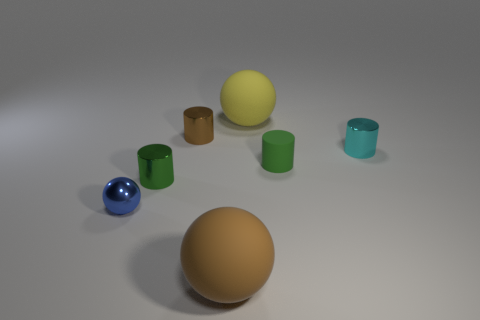What number of rubber things are big brown spheres or big yellow balls?
Ensure brevity in your answer.  2. There is a thing that is the same color as the matte cylinder; what is it made of?
Provide a short and direct response. Metal. Do the blue shiny sphere and the brown matte object have the same size?
Your answer should be very brief. No. How many things are either small spheres or matte balls that are in front of the small ball?
Offer a very short reply. 2. What material is the blue sphere that is the same size as the brown cylinder?
Your response must be concise. Metal. What is the cylinder that is behind the small rubber cylinder and on the right side of the yellow object made of?
Make the answer very short. Metal. Are there any cylinders that are behind the large yellow matte thing right of the tiny blue object?
Provide a short and direct response. No. What size is the object that is both right of the brown rubber thing and behind the cyan thing?
Ensure brevity in your answer.  Large. What number of purple things are either small cubes or small matte cylinders?
Offer a terse response. 0. What is the shape of the cyan metal object that is the same size as the green shiny object?
Give a very brief answer. Cylinder. 